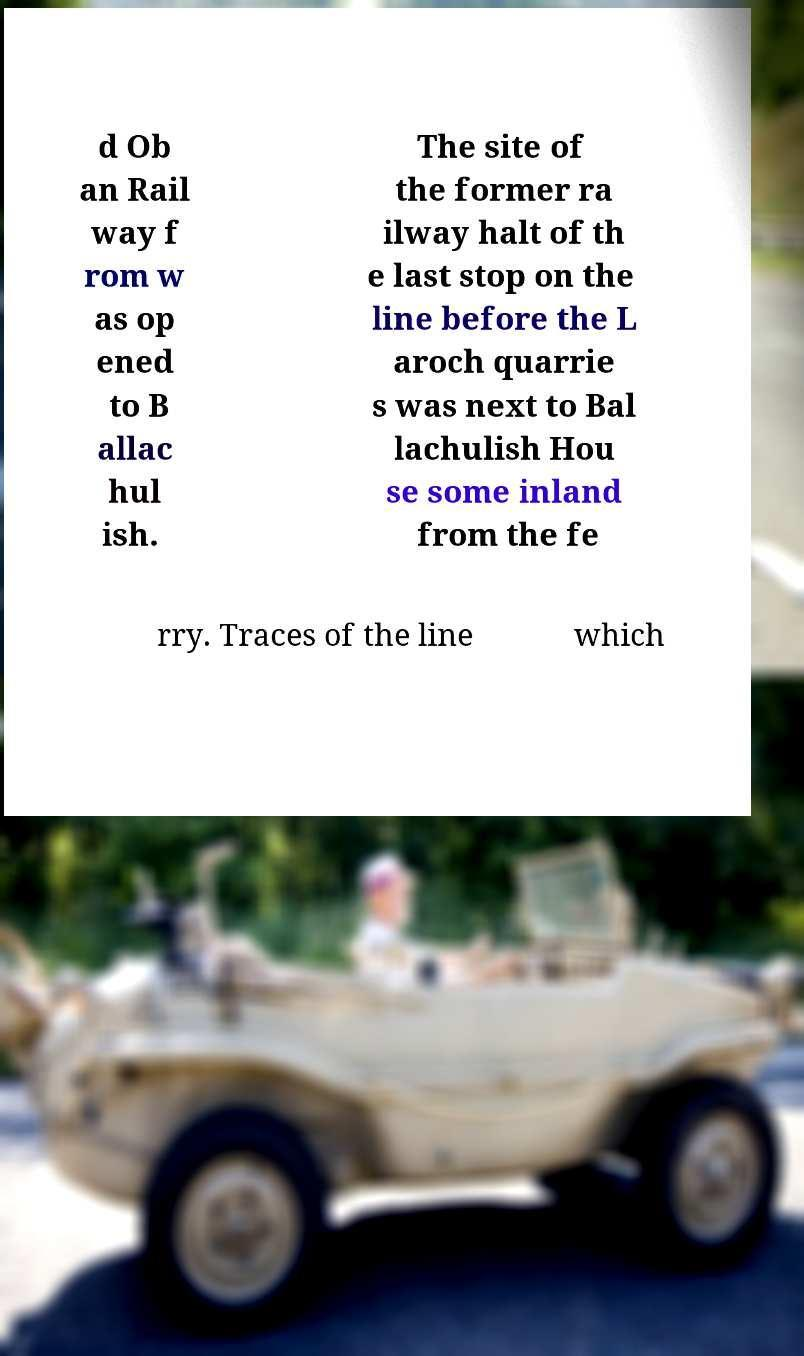Could you extract and type out the text from this image? d Ob an Rail way f rom w as op ened to B allac hul ish. The site of the former ra ilway halt of th e last stop on the line before the L aroch quarrie s was next to Bal lachulish Hou se some inland from the fe rry. Traces of the line which 